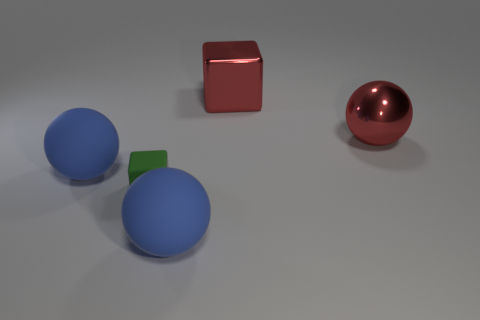Add 1 tiny blocks. How many objects exist? 6 Subtract all spheres. How many objects are left? 2 Add 3 big red objects. How many big red objects are left? 5 Add 2 large spheres. How many large spheres exist? 5 Subtract 0 gray balls. How many objects are left? 5 Subtract all large yellow matte objects. Subtract all green matte things. How many objects are left? 4 